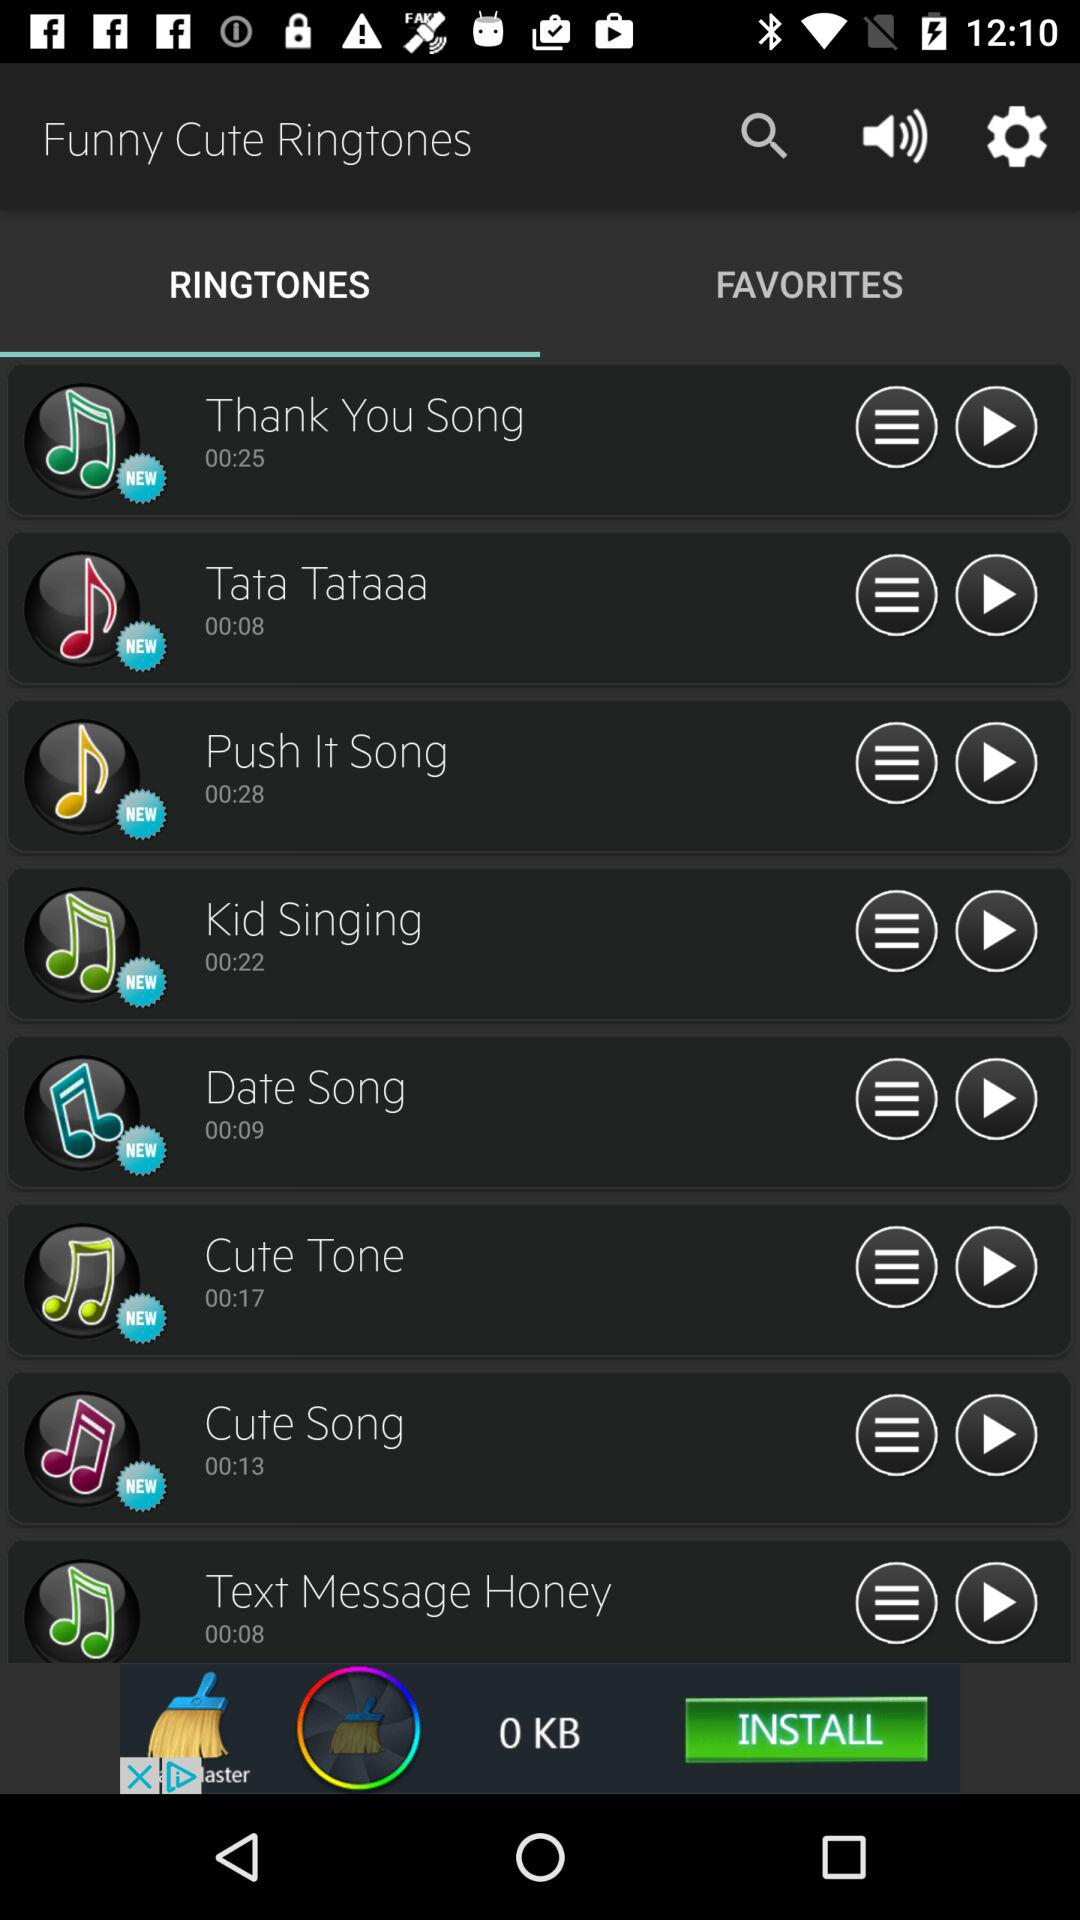What is the duration of the "Date Song" ringtone? The duration of the "Date Song" ringtone is 9 seconds. 